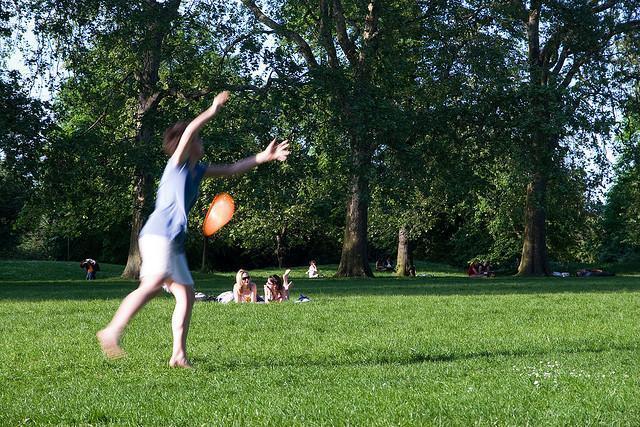How many girls are in the background?
Give a very brief answer. 2. 